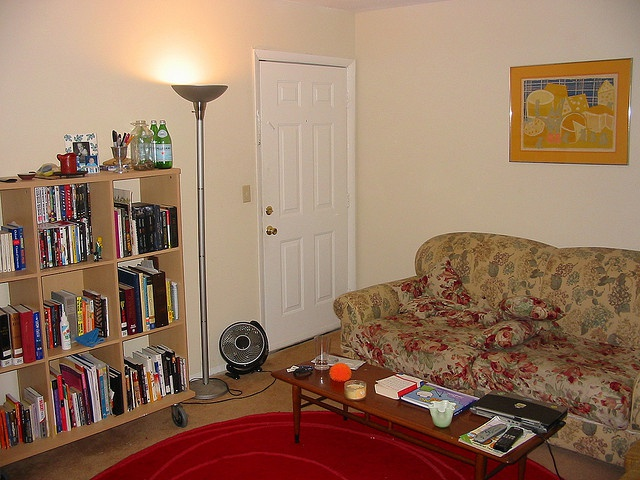Describe the objects in this image and their specific colors. I can see couch in darkgray, maroon, and gray tones, book in darkgray, black, and gray tones, book in darkgray, black, maroon, gray, and tan tones, book in darkgray, black, gray, and maroon tones, and book in darkgray, maroon, black, and gray tones in this image. 